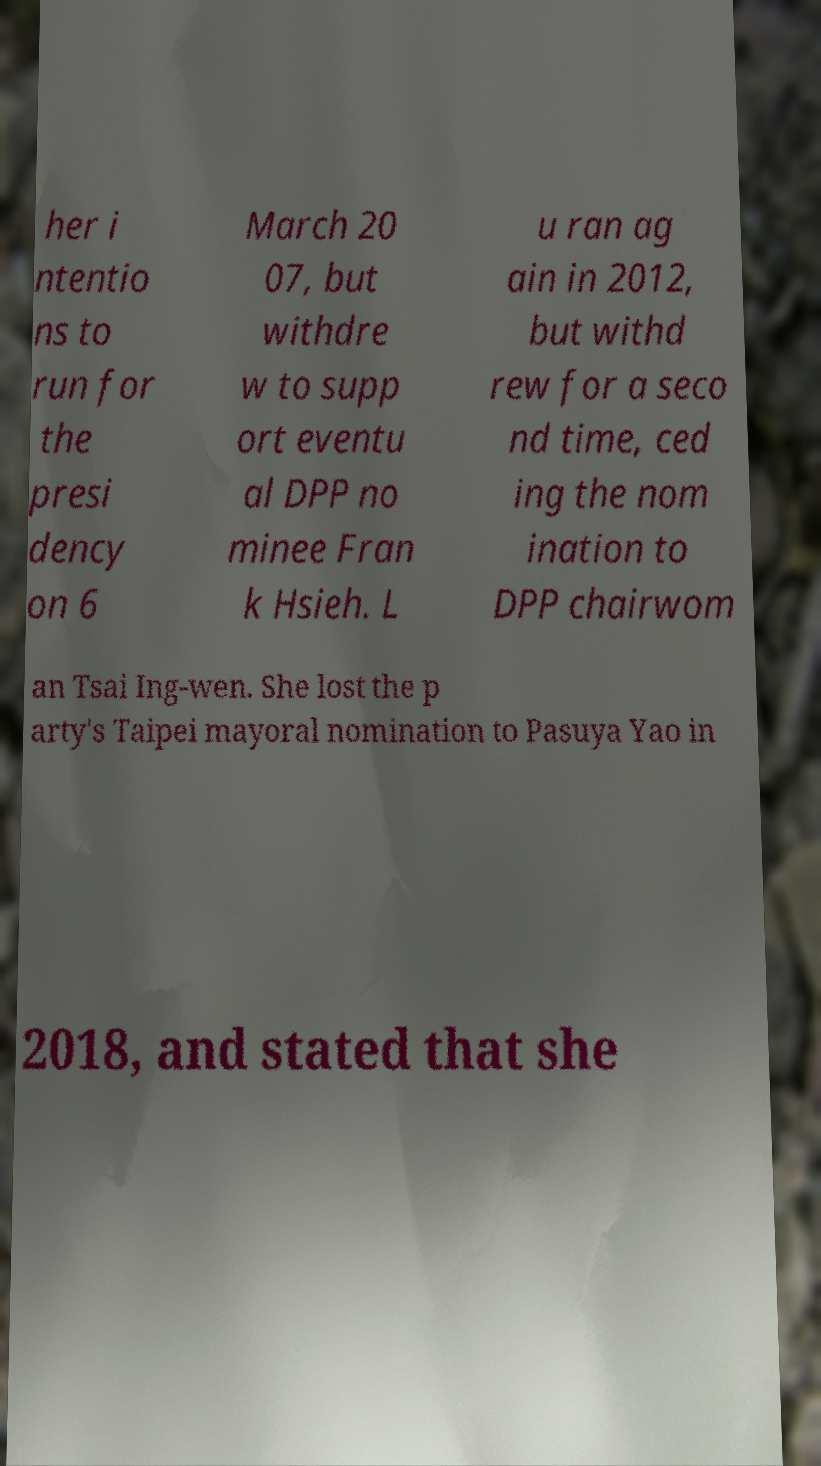I need the written content from this picture converted into text. Can you do that? her i ntentio ns to run for the presi dency on 6 March 20 07, but withdre w to supp ort eventu al DPP no minee Fran k Hsieh. L u ran ag ain in 2012, but withd rew for a seco nd time, ced ing the nom ination to DPP chairwom an Tsai Ing-wen. She lost the p arty's Taipei mayoral nomination to Pasuya Yao in 2018, and stated that she 